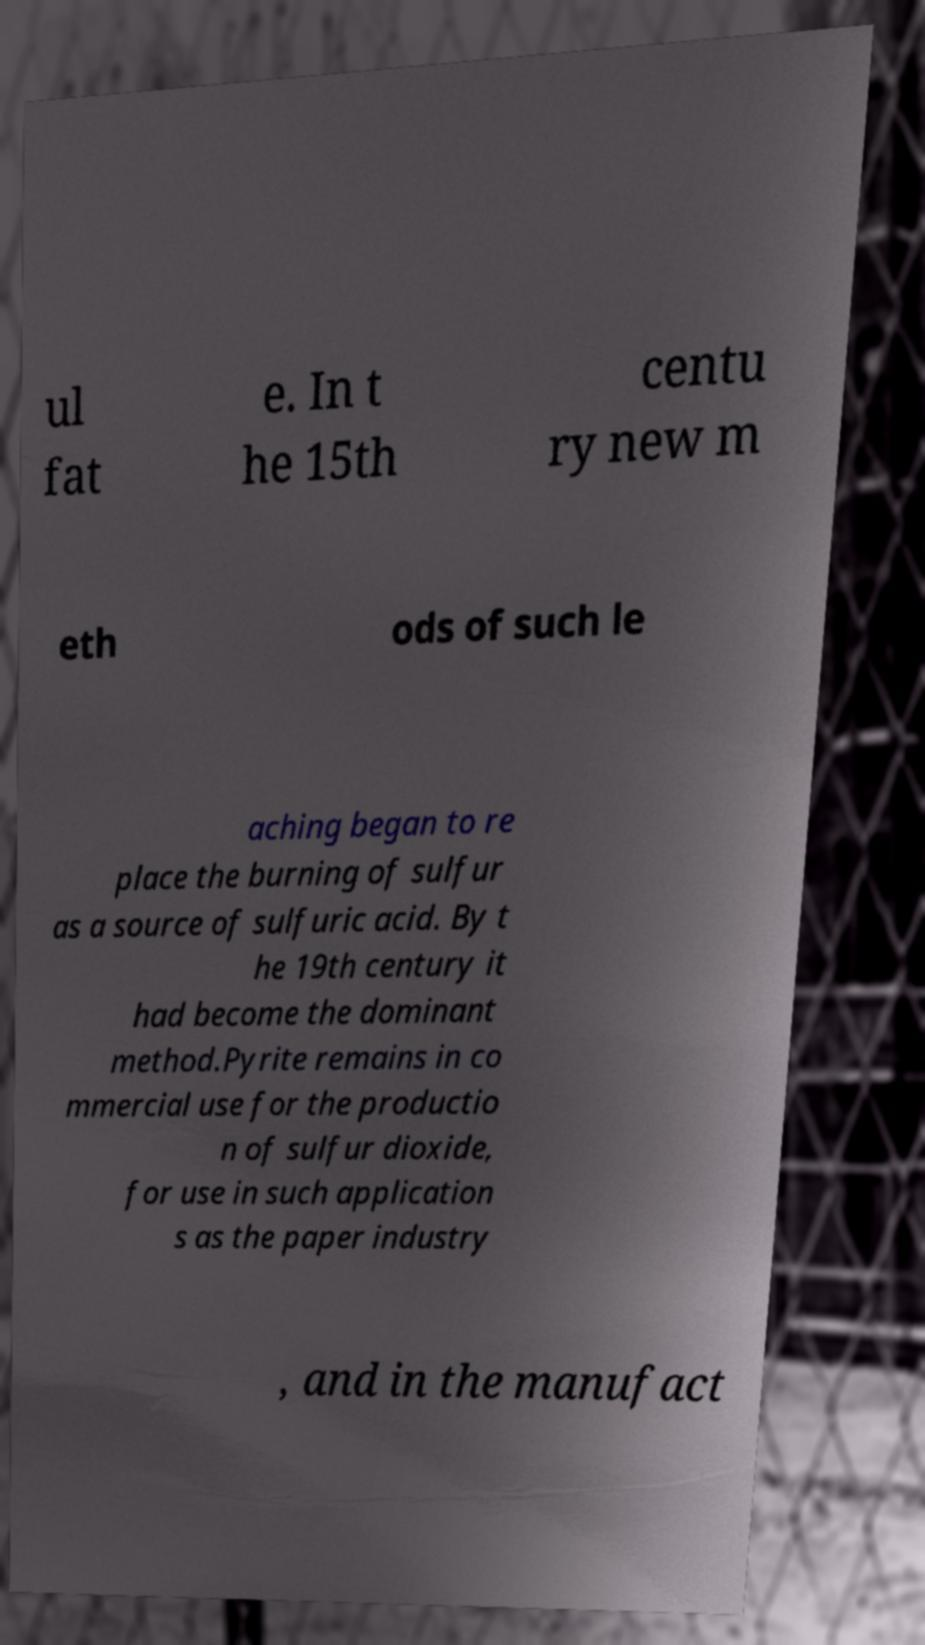For documentation purposes, I need the text within this image transcribed. Could you provide that? ul fat e. In t he 15th centu ry new m eth ods of such le aching began to re place the burning of sulfur as a source of sulfuric acid. By t he 19th century it had become the dominant method.Pyrite remains in co mmercial use for the productio n of sulfur dioxide, for use in such application s as the paper industry , and in the manufact 